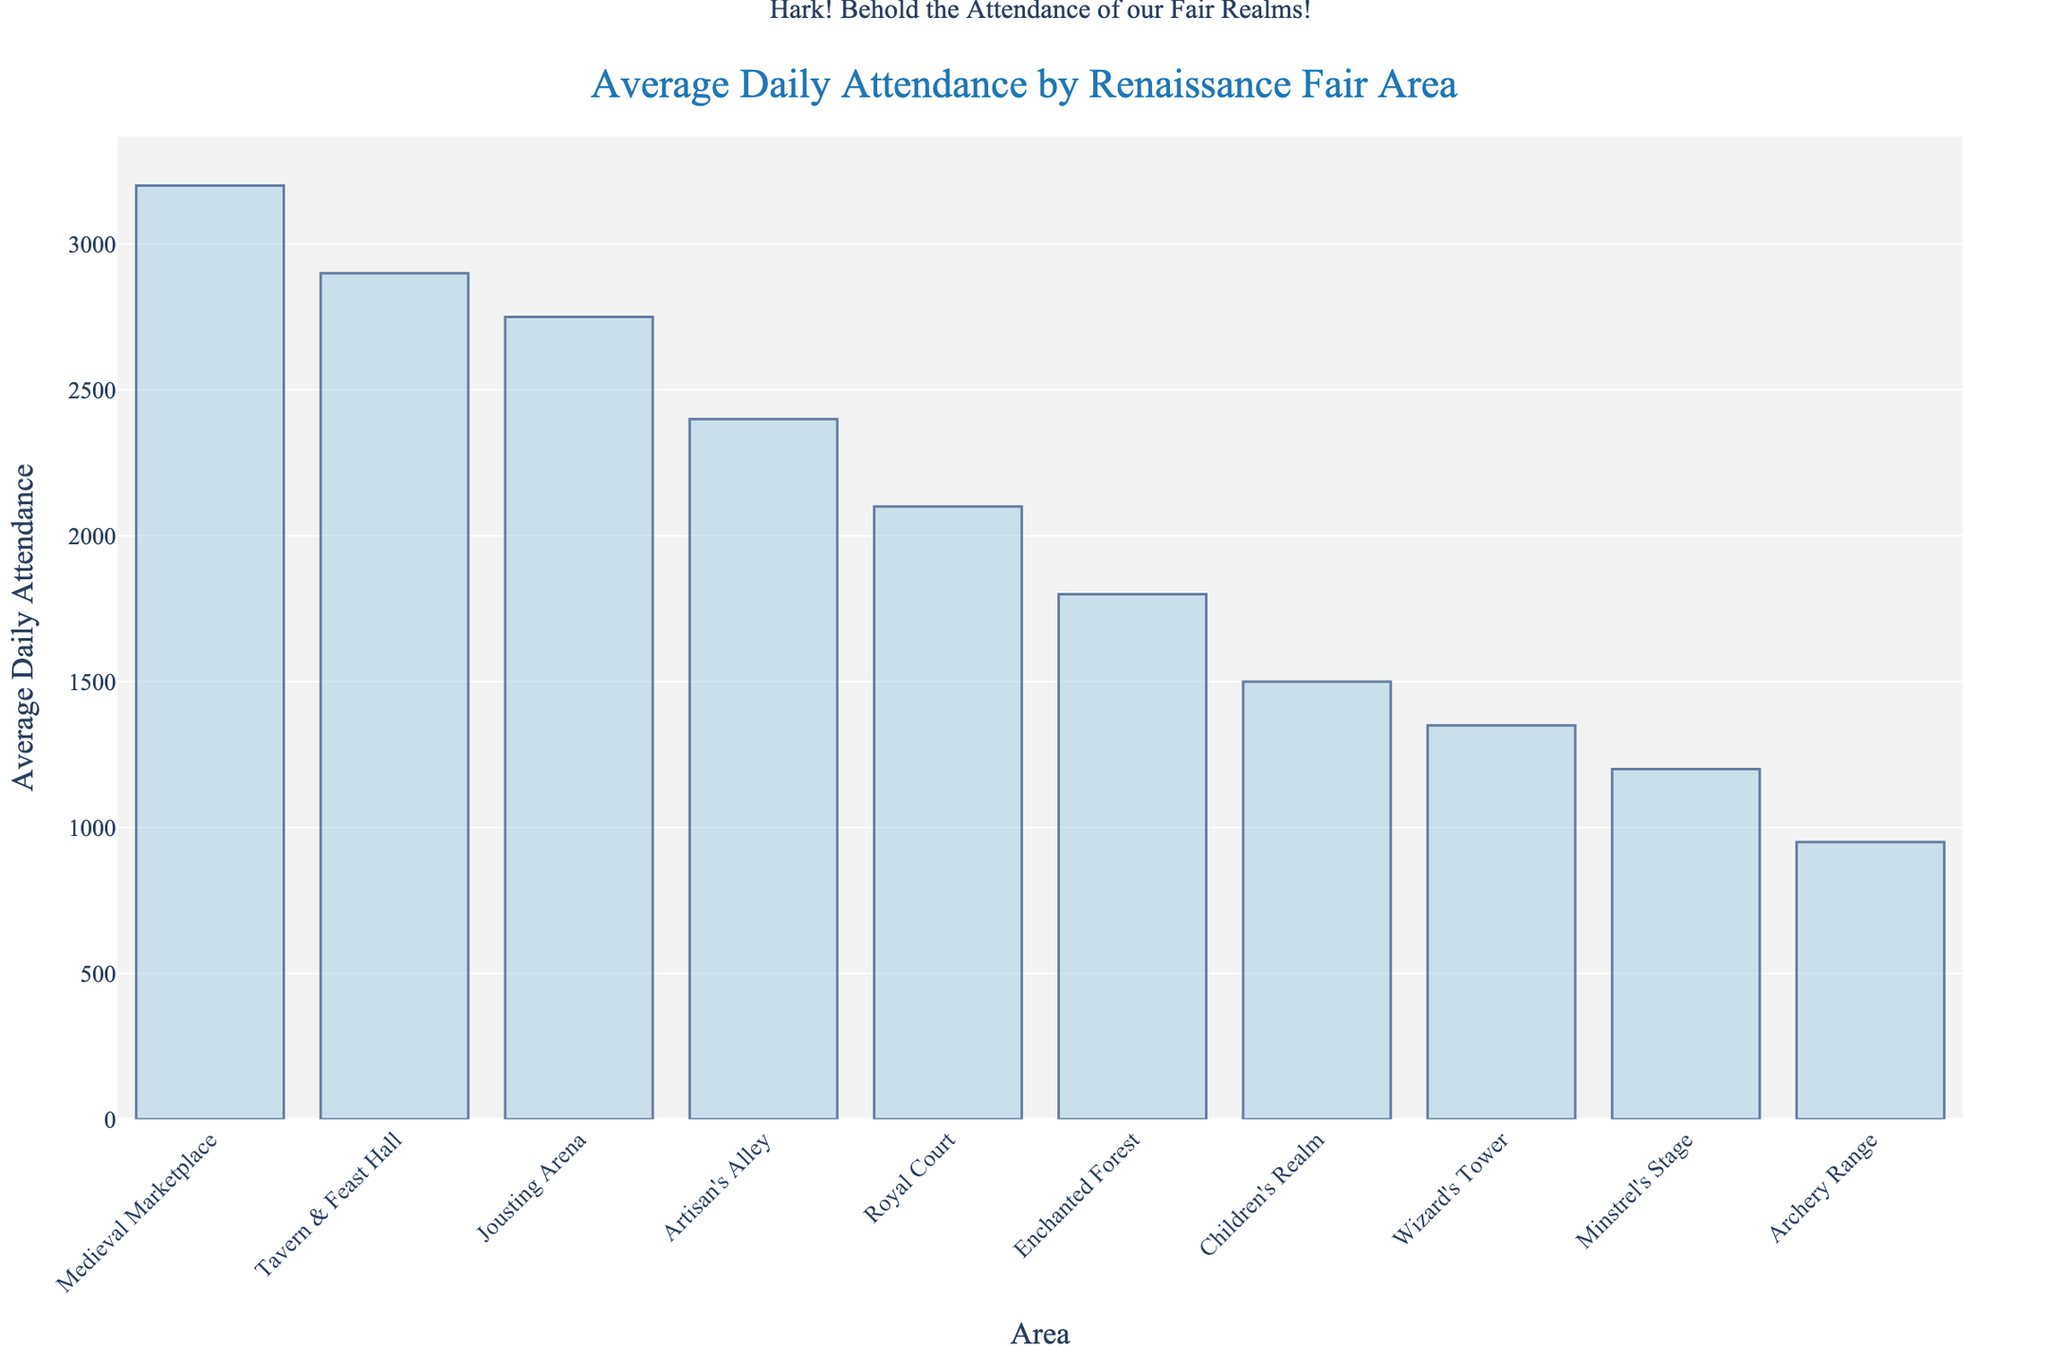Which area has the highest average daily attendance? Identify the tallest bar in the chart. The "Medieval Marketplace" has the highest average daily attendance as indicated by the tallest bar.
Answer: Medieval Marketplace Which two areas have the lowest average daily attendance, and how do they compare? Identify the two shortest bars in the chart and compare their heights. "Archery Range" and "Minstrel's Stage" have the lowest average daily attendances, with the "Archery Range" being slightly shorter.
Answer: Archery Range has lower attendance than Minstrel's Stage What's the combined average daily attendance of the Jousting Arena and the Tavern & Feast Hall? Find the heights of the bars for Jousting Arena (2750) and Tavern & Feast Hall (2900), and then sum them up: 2750 + 2900.
Answer: 5650 How much greater is the average daily attendance of the Artisan's Alley compared to the Wizard's Tower? Identify the heights of the bars for Artisan's Alley (2400) and Wizard's Tower (1350), and then subtract the latter from the former: 2400 - 1350.
Answer: 1050 What is the median average daily attendance value of all areas? Arrange the attendance values in ascending order and identify the middle value: 950, 1200, 1350, 1500, 1800, 2100, 2400, 2750, 2900, 3200. The median is the average of the 5th and 6th values: (1800 + 2100) / 2.
Answer: 1950 Which area has an average daily attendance closest to 2000? Identify the bar whose height is closest to 2000. "Royal Court" has the attendance value of 2100, which is the nearest to 2000.
Answer: Royal Court How does the average daily attendance of the Enchanted Forest compare to that of the Children's Realm? Identify the heights of the bars for Enchanted Forest (1800) and Children's Realm (1500), and determine which is higher. Enchanted Forest has higher average daily attendance.
Answer: Enchanted Forest has higher attendance than Children's Realm What's the difference in average daily attendance between the Jousting Arena and the Medieval Marketplace? Identify the heights of the bars for Jousting Arena (2750) and Medieval Marketplace (3200), and subtract the former from the latter: 3200 - 2750.
Answer: 450 How many areas have an average daily attendance greater than 2000? Count the bars whose heights exceed the 2000 mark. There are four such bars: Jousting Arena, Medieval Marketplace, Tavern & Feast Hall, and Artisan's Alley.
Answer: 4 What is the range (difference between highest and lowest) of average daily attendance values? Find the heights of the tallest bar (Medieval Marketplace, 3200) and the shortest bar (Archery Range, 950), then subtract the latter from the former: 3200 - 950.
Answer: 2250 